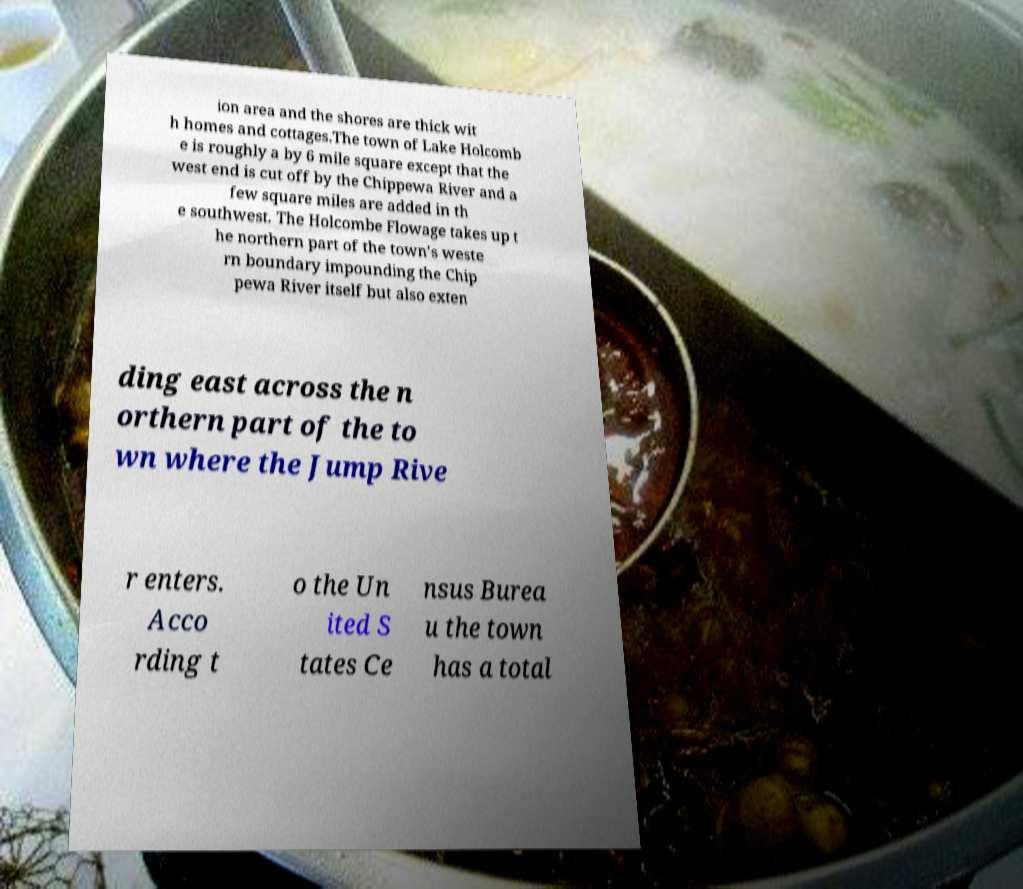Could you extract and type out the text from this image? ion area and the shores are thick wit h homes and cottages.The town of Lake Holcomb e is roughly a by 6 mile square except that the west end is cut off by the Chippewa River and a few square miles are added in th e southwest. The Holcombe Flowage takes up t he northern part of the town's weste rn boundary impounding the Chip pewa River itself but also exten ding east across the n orthern part of the to wn where the Jump Rive r enters. Acco rding t o the Un ited S tates Ce nsus Burea u the town has a total 